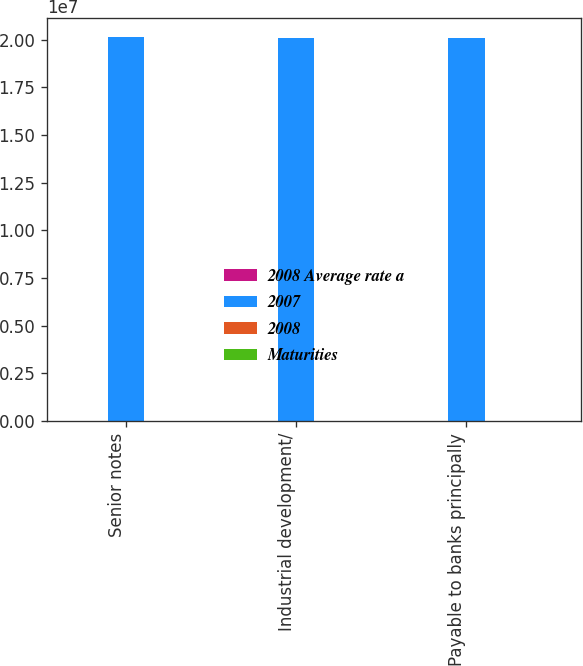Convert chart. <chart><loc_0><loc_0><loc_500><loc_500><stacked_bar_chart><ecel><fcel>Senior notes<fcel>Industrial development/<fcel>Payable to banks principally<nl><fcel>2008 Average rate a<fcel>5.11<fcel>1.1<fcel>6.93<nl><fcel>2007<fcel>2.0132e+07<fcel>2.0112e+07<fcel>2.0102e+07<nl><fcel>2008<fcel>8962<fcel>264<fcel>317<nl><fcel>Maturities<fcel>8957<fcel>266<fcel>1988<nl></chart> 